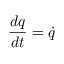Convert formula to latex. <formula><loc_0><loc_0><loc_500><loc_500>{ \frac { d q } { d t } } = { \dot { q } }</formula> 